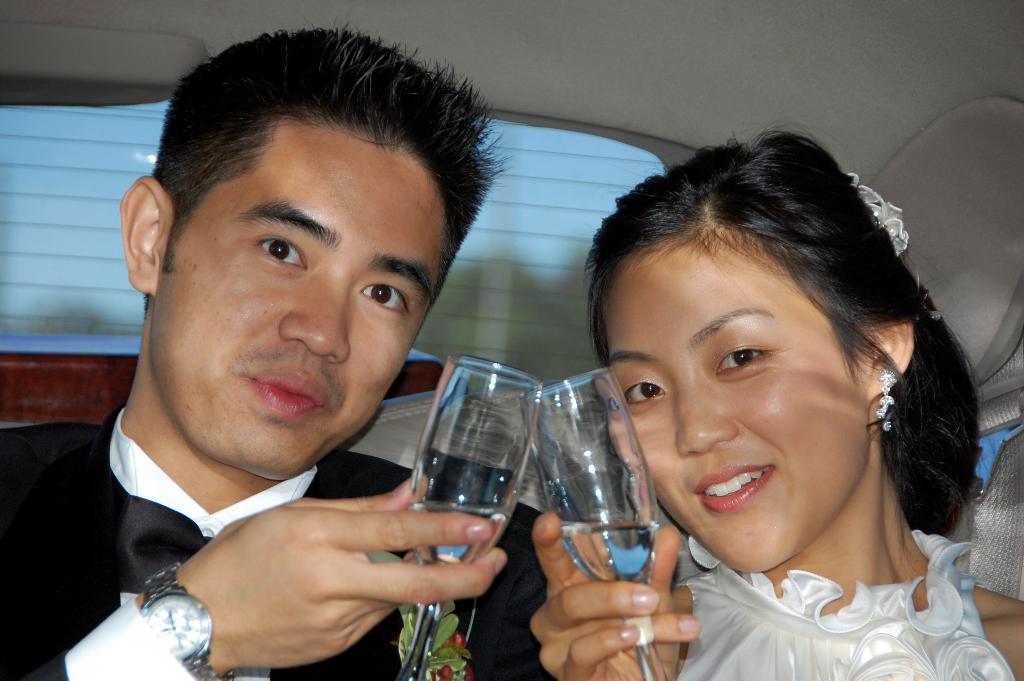Who is present in the image? There is a couple in the image. Where are the couple located? The couple is sitting inside a car. What are the couple holding in their hands? The couple is holding a glass of wine in their hands. How many chickens can be seen in the image? There are no chickens present in the image. What type of chalk is the fireman using to draw on the car? There is no fireman or chalk present in the image. 